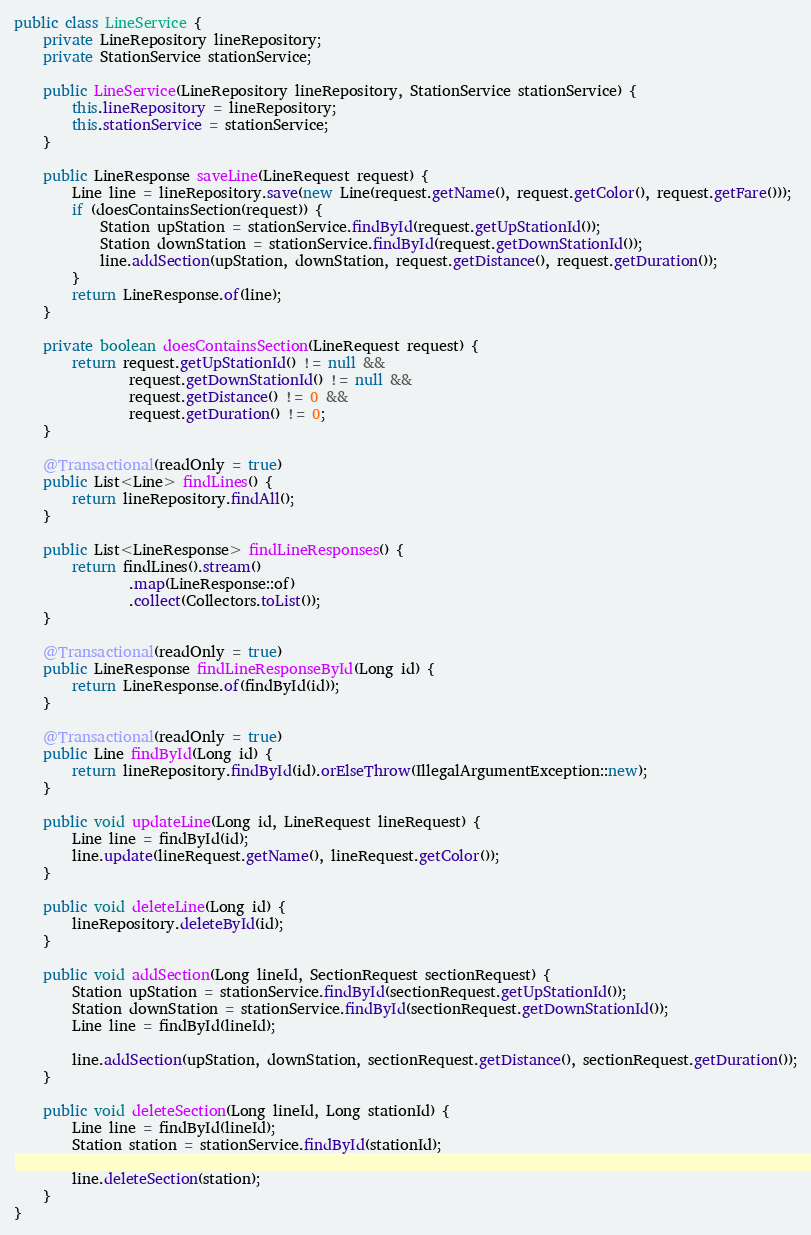Convert code to text. <code><loc_0><loc_0><loc_500><loc_500><_Java_>public class LineService {
    private LineRepository lineRepository;
    private StationService stationService;

    public LineService(LineRepository lineRepository, StationService stationService) {
        this.lineRepository = lineRepository;
        this.stationService = stationService;
    }

    public LineResponse saveLine(LineRequest request) {
        Line line = lineRepository.save(new Line(request.getName(), request.getColor(), request.getFare()));
        if (doesContainsSection(request)) {
            Station upStation = stationService.findById(request.getUpStationId());
            Station downStation = stationService.findById(request.getDownStationId());
            line.addSection(upStation, downStation, request.getDistance(), request.getDuration());
        }
        return LineResponse.of(line);
    }

    private boolean doesContainsSection(LineRequest request) {
        return request.getUpStationId() != null &&
                request.getDownStationId() != null &&
                request.getDistance() != 0 &&
                request.getDuration() != 0;
    }

    @Transactional(readOnly = true)
    public List<Line> findLines() {
        return lineRepository.findAll();
    }

    public List<LineResponse> findLineResponses() {
        return findLines().stream()
                .map(LineResponse::of)
                .collect(Collectors.toList());
    }

    @Transactional(readOnly = true)
    public LineResponse findLineResponseById(Long id) {
        return LineResponse.of(findById(id));
    }

    @Transactional(readOnly = true)
    public Line findById(Long id) {
        return lineRepository.findById(id).orElseThrow(IllegalArgumentException::new);
    }

    public void updateLine(Long id, LineRequest lineRequest) {
        Line line = findById(id);
        line.update(lineRequest.getName(), lineRequest.getColor());
    }

    public void deleteLine(Long id) {
        lineRepository.deleteById(id);
    }

    public void addSection(Long lineId, SectionRequest sectionRequest) {
        Station upStation = stationService.findById(sectionRequest.getUpStationId());
        Station downStation = stationService.findById(sectionRequest.getDownStationId());
        Line line = findById(lineId);

        line.addSection(upStation, downStation, sectionRequest.getDistance(), sectionRequest.getDuration());
    }

    public void deleteSection(Long lineId, Long stationId) {
        Line line = findById(lineId);
        Station station = stationService.findById(stationId);

        line.deleteSection(station);
    }
}
</code> 